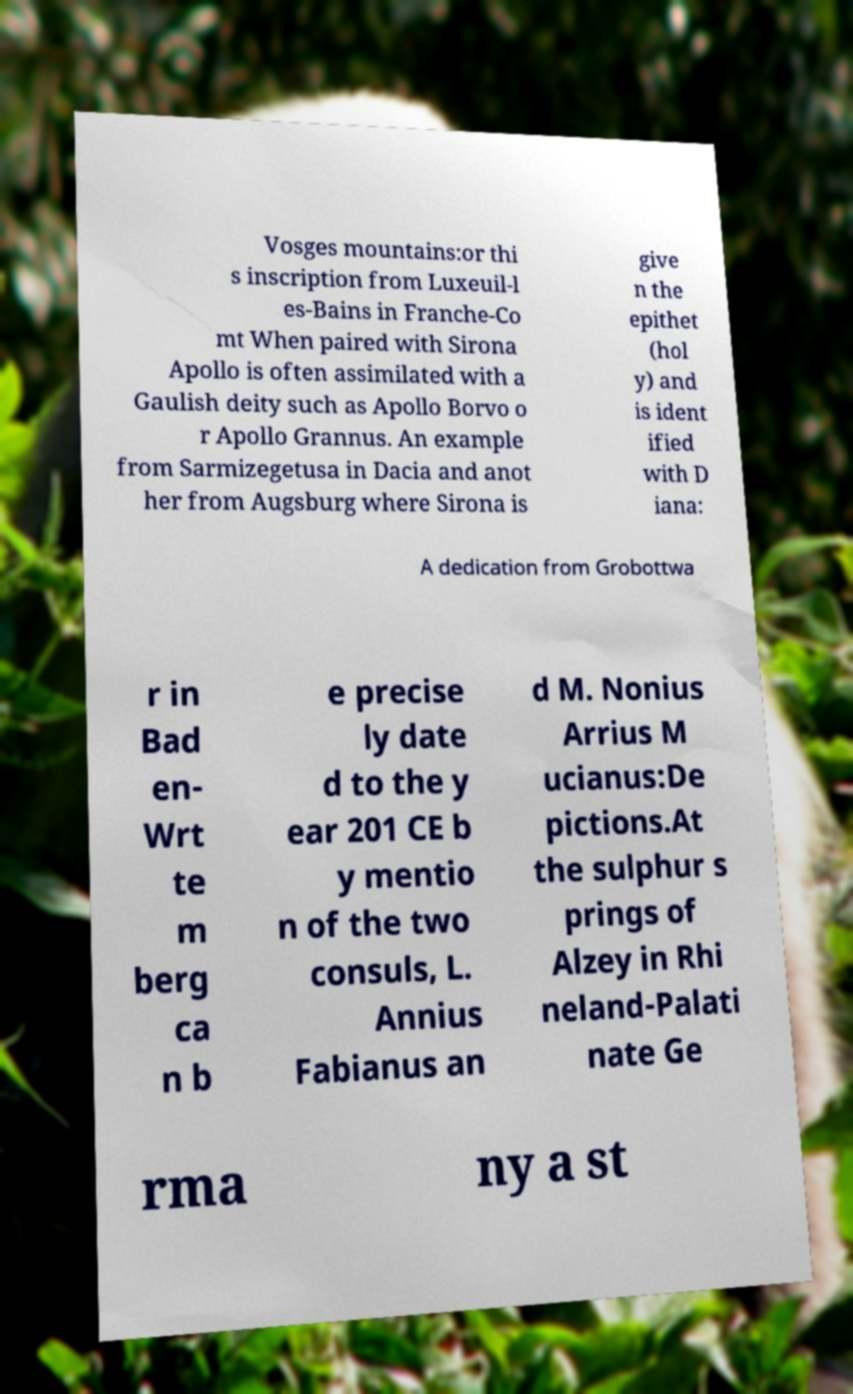Please read and relay the text visible in this image. What does it say? Vosges mountains:or thi s inscription from Luxeuil-l es-Bains in Franche-Co mt When paired with Sirona Apollo is often assimilated with a Gaulish deity such as Apollo Borvo o r Apollo Grannus. An example from Sarmizegetusa in Dacia and anot her from Augsburg where Sirona is give n the epithet (hol y) and is ident ified with D iana: A dedication from Grobottwa r in Bad en- Wrt te m berg ca n b e precise ly date d to the y ear 201 CE b y mentio n of the two consuls, L. Annius Fabianus an d M. Nonius Arrius M ucianus:De pictions.At the sulphur s prings of Alzey in Rhi neland-Palati nate Ge rma ny a st 